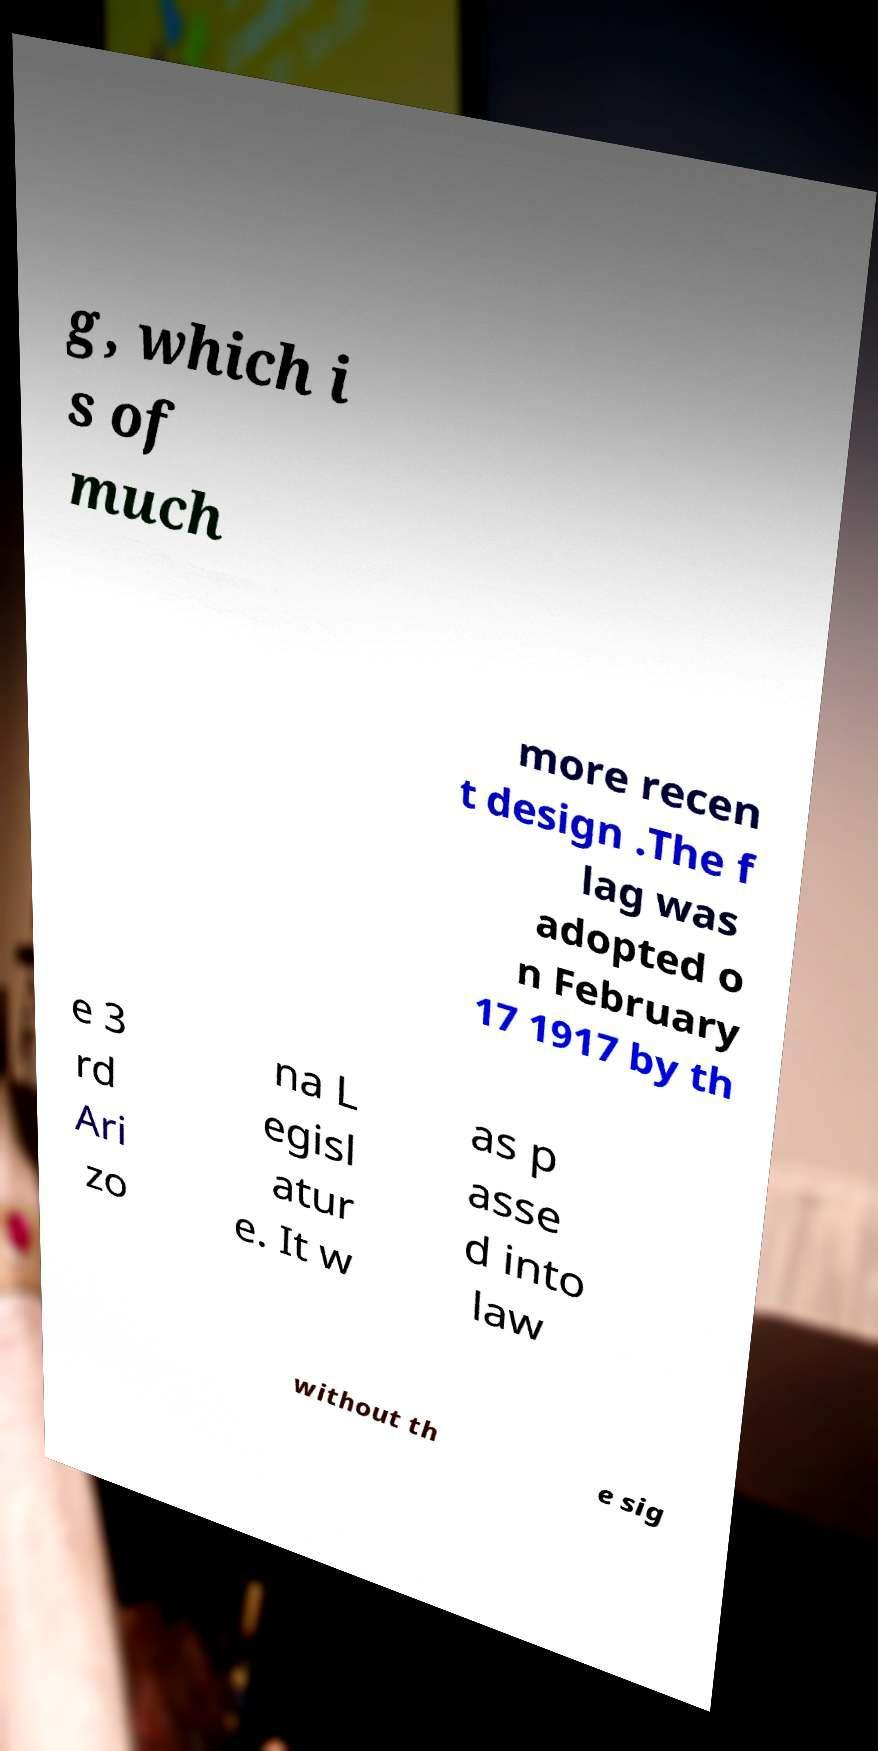For documentation purposes, I need the text within this image transcribed. Could you provide that? g, which i s of much more recen t design .The f lag was adopted o n February 17 1917 by th e 3 rd Ari zo na L egisl atur e. It w as p asse d into law without th e sig 